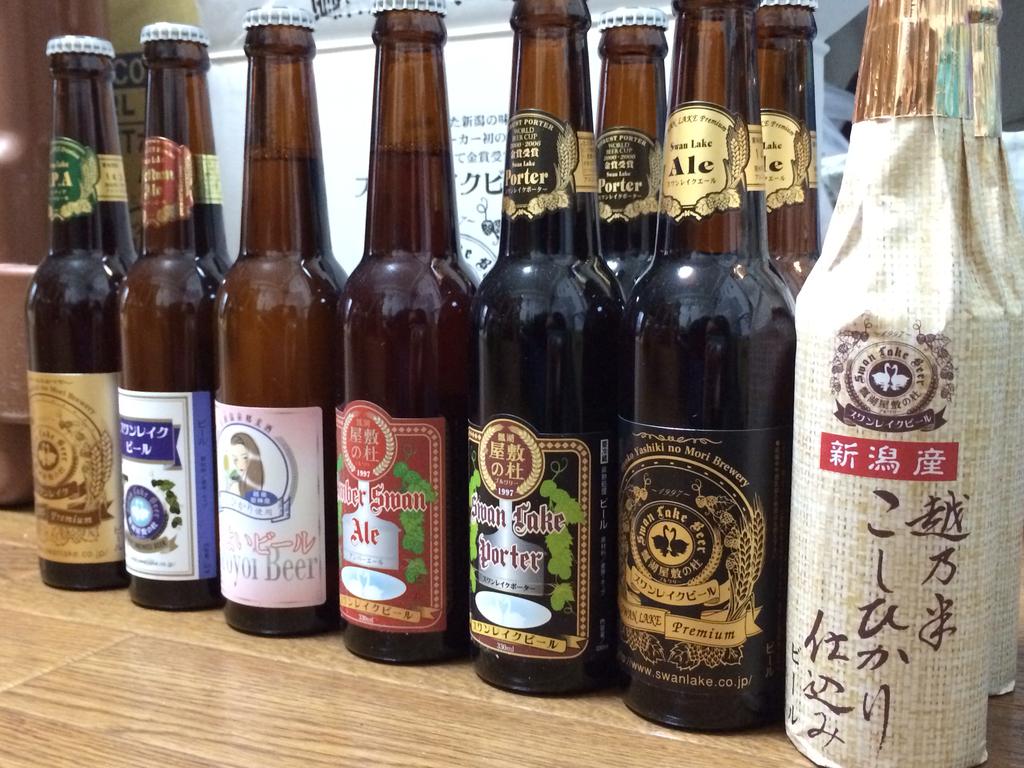What country is the wrapped bottle from?
Provide a succinct answer. Unanswerable. What ale can be seen here?
Offer a terse response. Swan lake. 